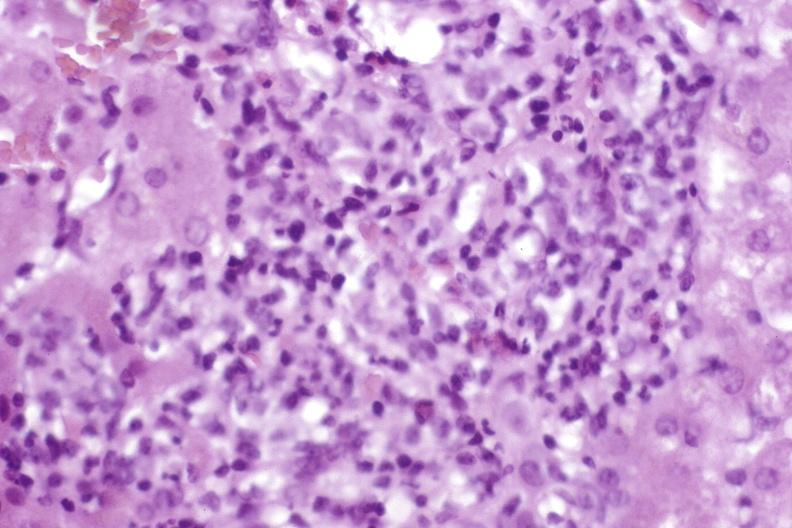s cytomegaly present?
Answer the question using a single word or phrase. No 